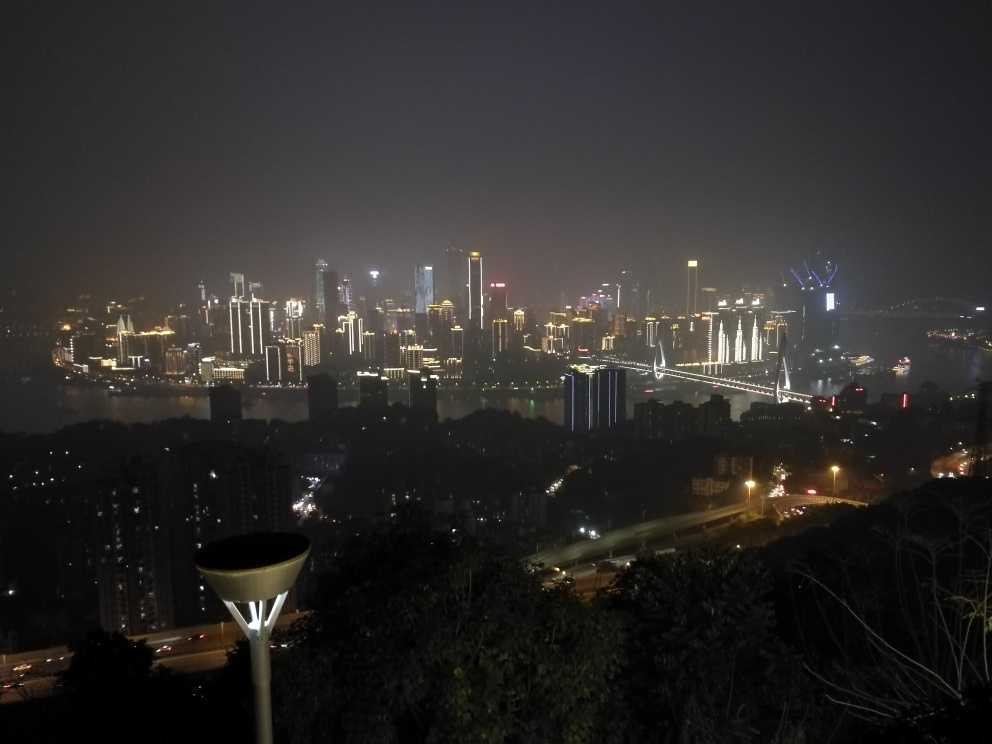Is the main subject very clear?
A. No
B. Yes
Answer with the option's letter from the given choices directly. The clarity of the main subject in the image can be considered subjective; however, upon close examination, one can ascertain that the skyline and illuminated buildings form the primary focus. Although the cityscape is visually prominent, factors such as the time of day (nighttime) and atmospheric conditions may affect the perception of clarity. Nonetheless, the bright lights against the darker sky draw attention to the urban landscape as the main subject. Hence, the answer would be B. Yes. 